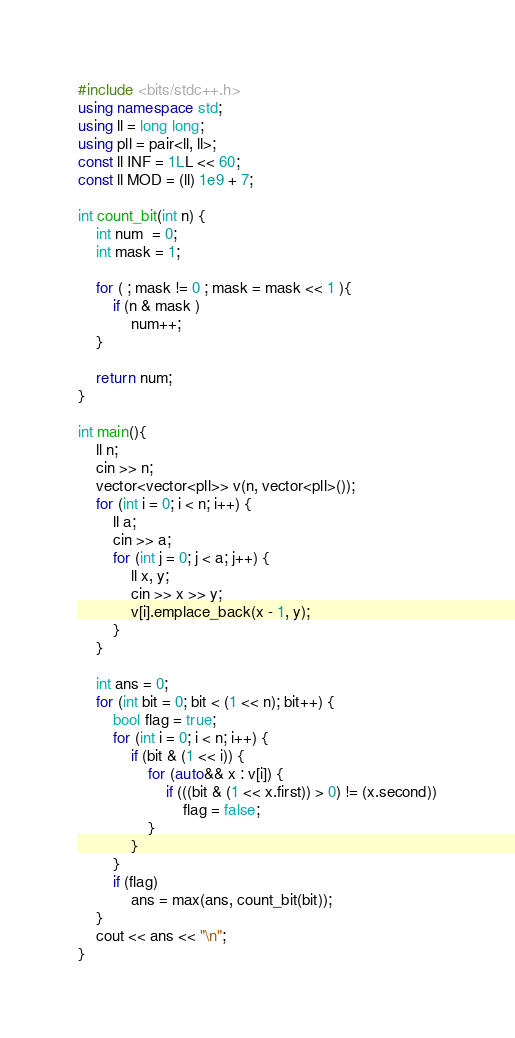<code> <loc_0><loc_0><loc_500><loc_500><_C++_>#include <bits/stdc++.h>
using namespace std;
using ll = long long;
using pll = pair<ll, ll>;
const ll INF = 1LL << 60;
const ll MOD = (ll) 1e9 + 7;

int count_bit(int n) {
    int num  = 0;
    int mask = 1;

    for ( ; mask != 0 ; mask = mask << 1 ){
        if (n & mask )
            num++;
    }

    return num;
}

int main(){
    ll n;
    cin >> n;
    vector<vector<pll>> v(n, vector<pll>());
    for (int i = 0; i < n; i++) {
        ll a;
        cin >> a;
        for (int j = 0; j < a; j++) {
            ll x, y;
            cin >> x >> y;
            v[i].emplace_back(x - 1, y);
        }
    }

    int ans = 0;
    for (int bit = 0; bit < (1 << n); bit++) {
        bool flag = true;
        for (int i = 0; i < n; i++) {
            if (bit & (1 << i)) {
                for (auto&& x : v[i]) {
                    if (((bit & (1 << x.first)) > 0) != (x.second))
                        flag = false;
                }
            }
        }
        if (flag)
            ans = max(ans, count_bit(bit));
    }
    cout << ans << "\n";
}</code> 